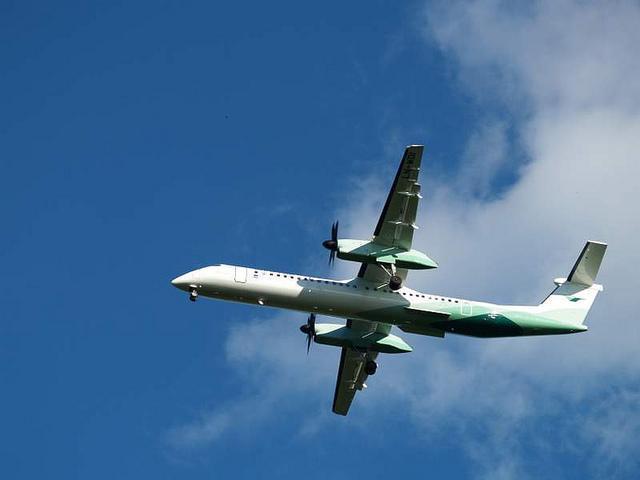How many engines does the airplane have?
Give a very brief answer. 2. How many clouds are visible in this photo?
Give a very brief answer. 1. How many dogs are on he bench in this image?
Give a very brief answer. 0. 